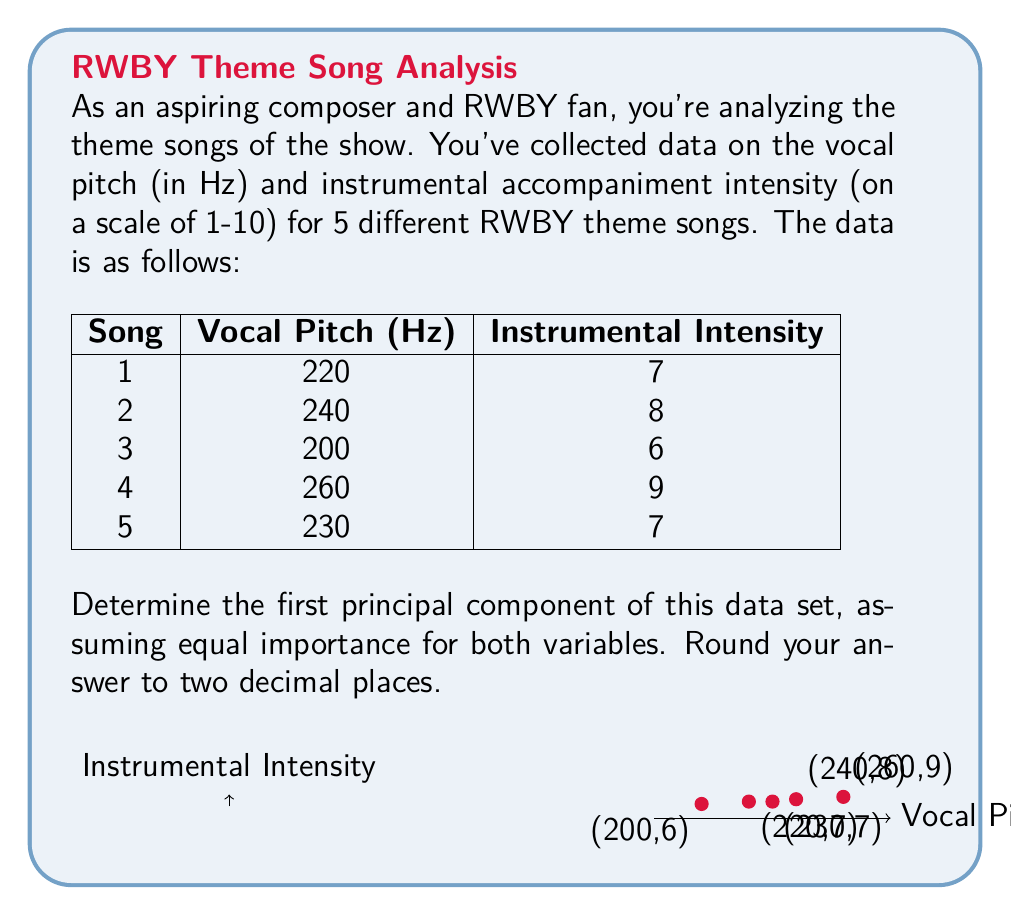Give your solution to this math problem. To find the first principal component, we need to follow these steps:

1) First, standardize the data. For each variable, subtract the mean and divide by the standard deviation.

   For vocal pitch (x):
   Mean: $\mu_x = \frac{220 + 240 + 200 + 260 + 230}{5} = 230$ Hz
   Standard deviation: $\sigma_x = \sqrt{\frac{(220-230)^2 + (240-230)^2 + (200-230)^2 + (260-230)^2 + (230-230)^2}{5-1}} \approx 22.36$ Hz

   For instrumental intensity (y):
   Mean: $\mu_y = \frac{7 + 8 + 6 + 9 + 7}{5} = 7.4$
   Standard deviation: $\sigma_y = \sqrt{\frac{(7-7.4)^2 + (8-7.4)^2 + (6-7.4)^2 + (9-7.4)^2 + (7-7.4)^2}{5-1}} \approx 1.14$

2) Standardized data:
   Song 1: $(-0.45, -0.35)$
   Song 2: $(0.45, 0.53)$
   Song 3: $(-1.34, -1.23)$
   Song 4: $(1.34, 1.40)$
   Song 5: $(0, -0.35)$

3) Calculate the covariance matrix:
   $$C = \begin{bmatrix}
   1 & r \\
   r & 1
   \end{bmatrix}$$
   where $r$ is the correlation coefficient.

   $r = \frac{\sum_{i=1}^{5} (x_i - \bar{x})(y_i - \bar{y})}{\sqrt{\sum_{i=1}^{5} (x_i - \bar{x})^2 \sum_{i=1}^{5} (y_i - \bar{y})^2}} \approx 0.9749$

4) Find eigenvalues of C:
   $det(C - \lambda I) = (1-\lambda)^2 - r^2 = 0$
   $\lambda_1 = 1 + r \approx 1.9749$
   $\lambda_2 = 1 - r \approx 0.0251$

5) Find eigenvector for $\lambda_1$:
   $(C - \lambda_1 I)v = 0$
   $\begin{bmatrix}
   -r & r \\
   r & -r
   \end{bmatrix}v = 0$

   This gives us $v = [\frac{1}{\sqrt{2}}, \frac{1}{\sqrt{2}}]^T$

6) The first principal component is this eigenvector:
   $PC_1 = [\frac{1}{\sqrt{2}}, \frac{1}{\sqrt{2}}]^T \approx [0.71, 0.71]^T$
Answer: $[0.71, 0.71]^T$ 